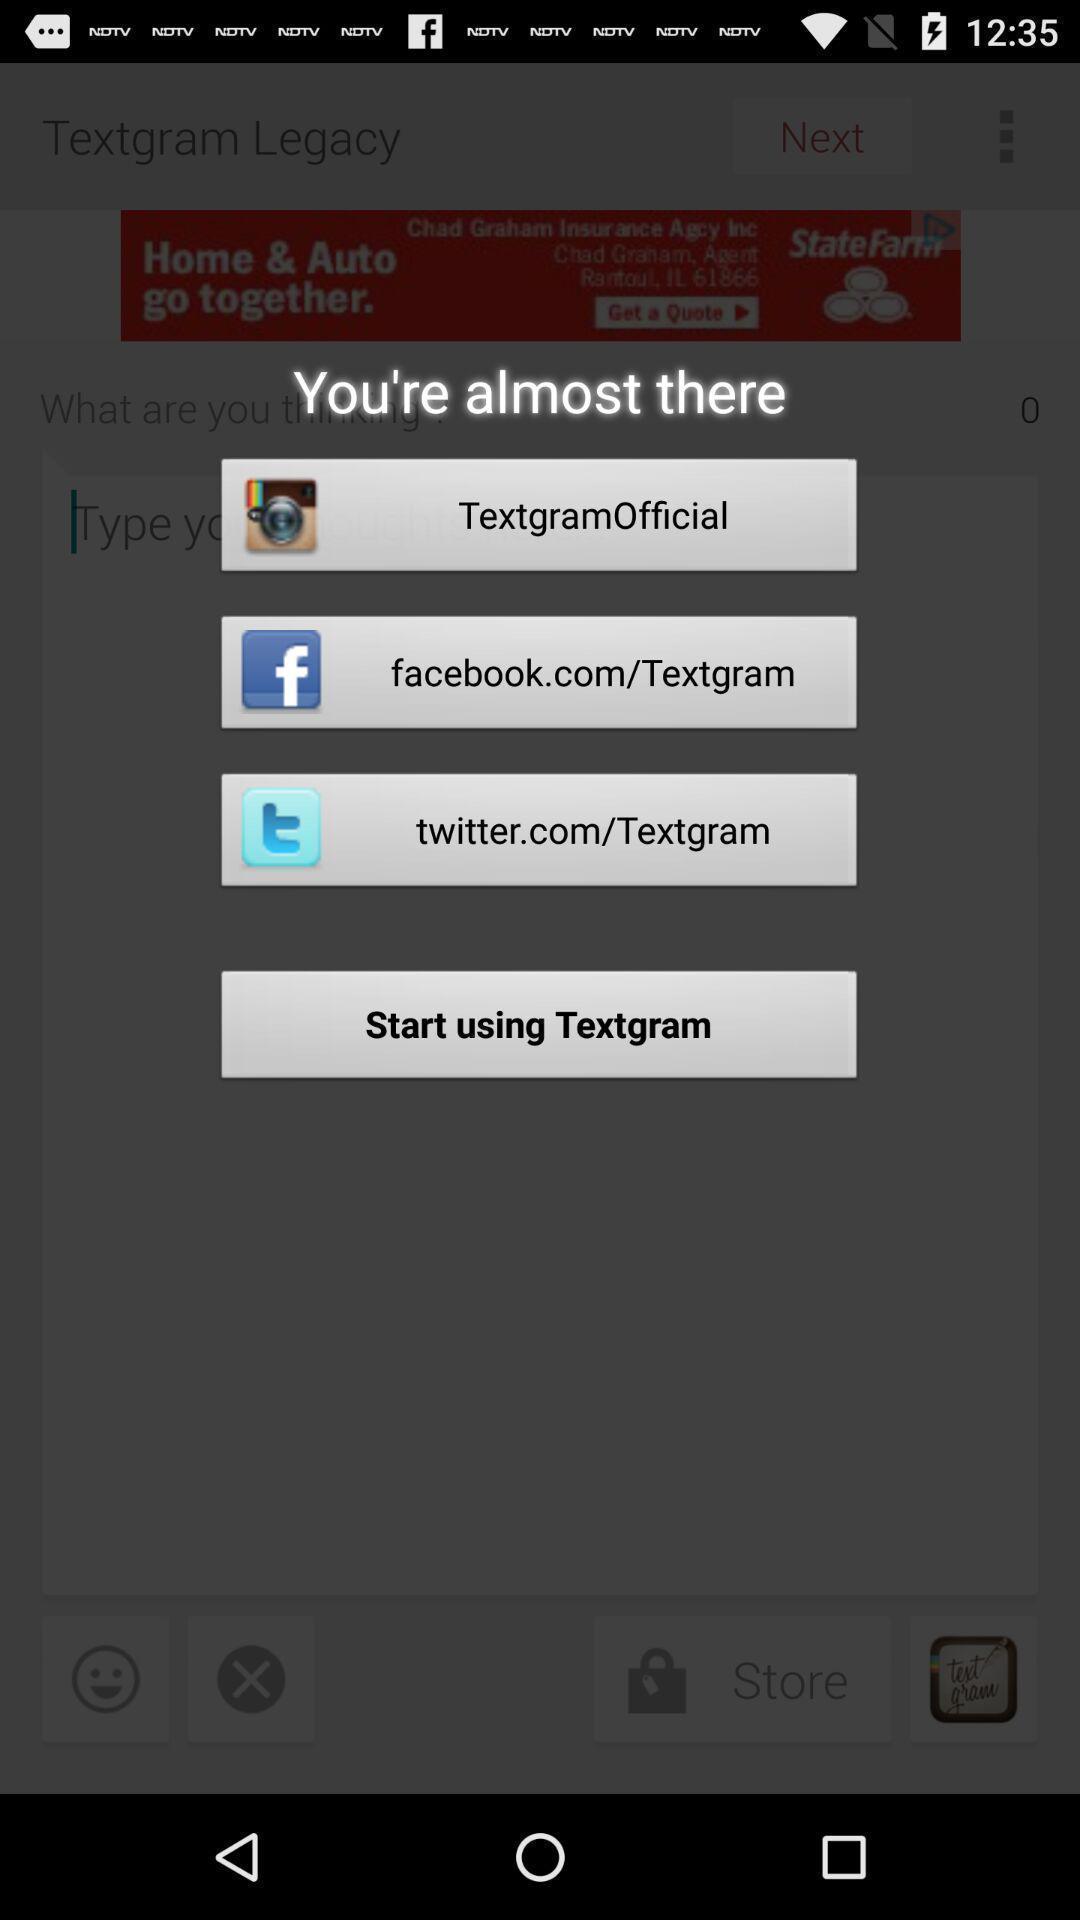Provide a detailed account of this screenshot. Popup displaying multiple social apps to select. 